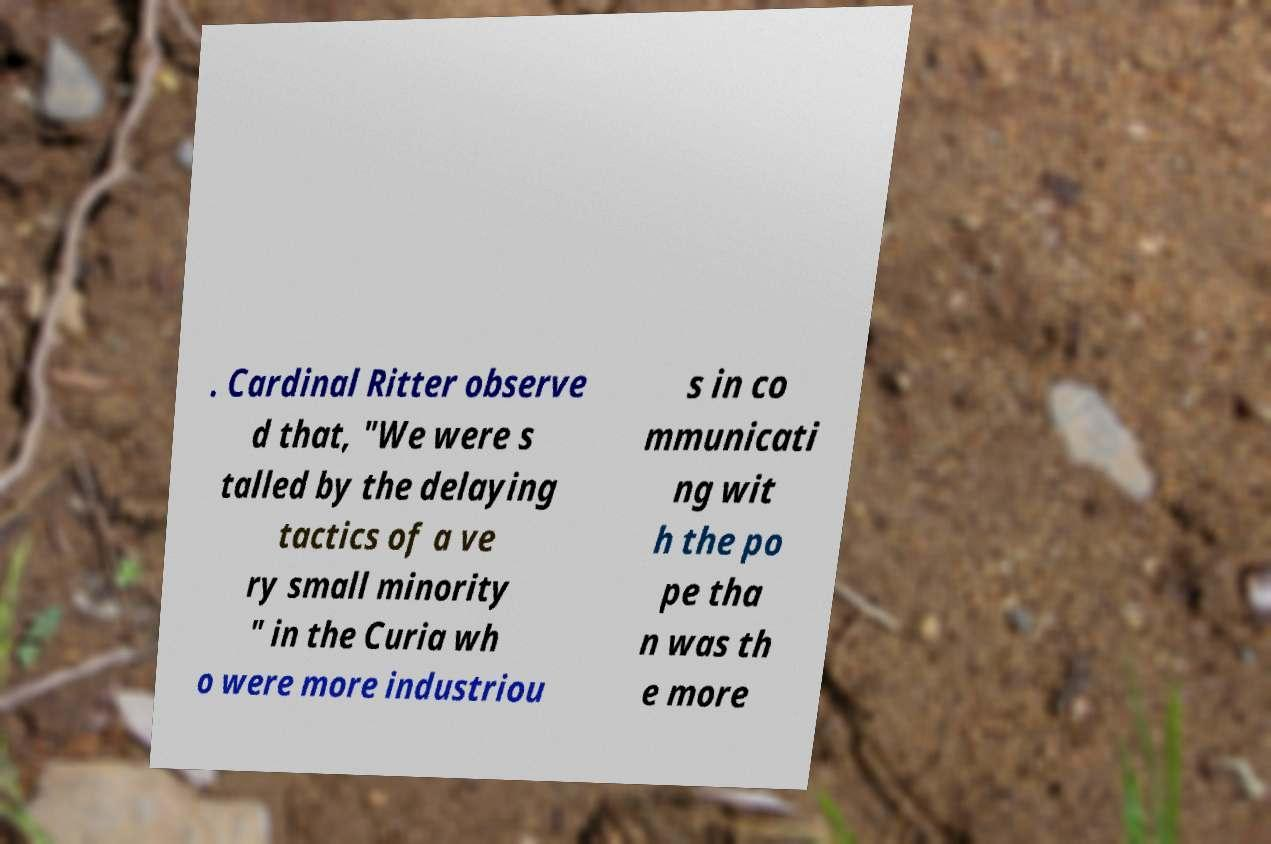For documentation purposes, I need the text within this image transcribed. Could you provide that? . Cardinal Ritter observe d that, "We were s talled by the delaying tactics of a ve ry small minority " in the Curia wh o were more industriou s in co mmunicati ng wit h the po pe tha n was th e more 